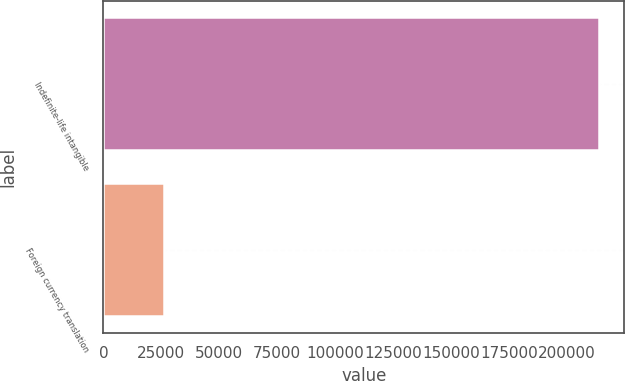Convert chart. <chart><loc_0><loc_0><loc_500><loc_500><bar_chart><fcel>Indefinite-life intangible<fcel>Foreign currency translation<nl><fcel>214112<fcel>26074<nl></chart> 